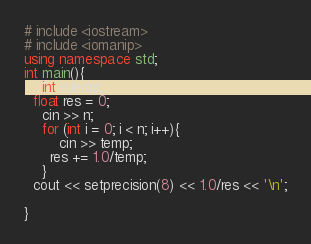<code> <loc_0><loc_0><loc_500><loc_500><_C++_># include <iostream>
# include <iomanip>
using namespace std;
int main(){
	int n,temp;
  float res = 0;
  	cin >> n;
  	for (int i = 0; i < n; i++){
    	cin >> temp;
      res += 1.0/temp;    
    }
  cout << setprecision(8) << 1.0/res << '\n';

}</code> 